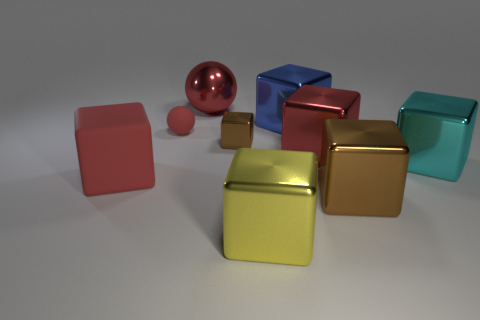There is a yellow thing that is the same shape as the large cyan object; what is it made of?
Ensure brevity in your answer.  Metal. Are there any other things that have the same material as the big brown object?
Ensure brevity in your answer.  Yes. Do the tiny metal block and the matte cube have the same color?
Your answer should be compact. No. There is a small rubber thing that is behind the brown metal block that is right of the blue metallic object; what is its shape?
Give a very brief answer. Sphere. What number of other things are there of the same shape as the small brown object?
Ensure brevity in your answer.  6. There is a yellow shiny cube in front of the cyan thing; is its size the same as the red matte ball?
Your answer should be compact. No. Are there more blue things that are in front of the small metallic object than large red matte spheres?
Your response must be concise. No. There is a brown block in front of the cyan shiny thing; what number of big metallic things are in front of it?
Your answer should be very brief. 1. Are there fewer red spheres that are behind the big metallic sphere than small red things?
Offer a terse response. Yes. There is a big metal cube that is behind the tiny thing that is on the right side of the red metallic sphere; are there any tiny red things that are in front of it?
Make the answer very short. Yes. 